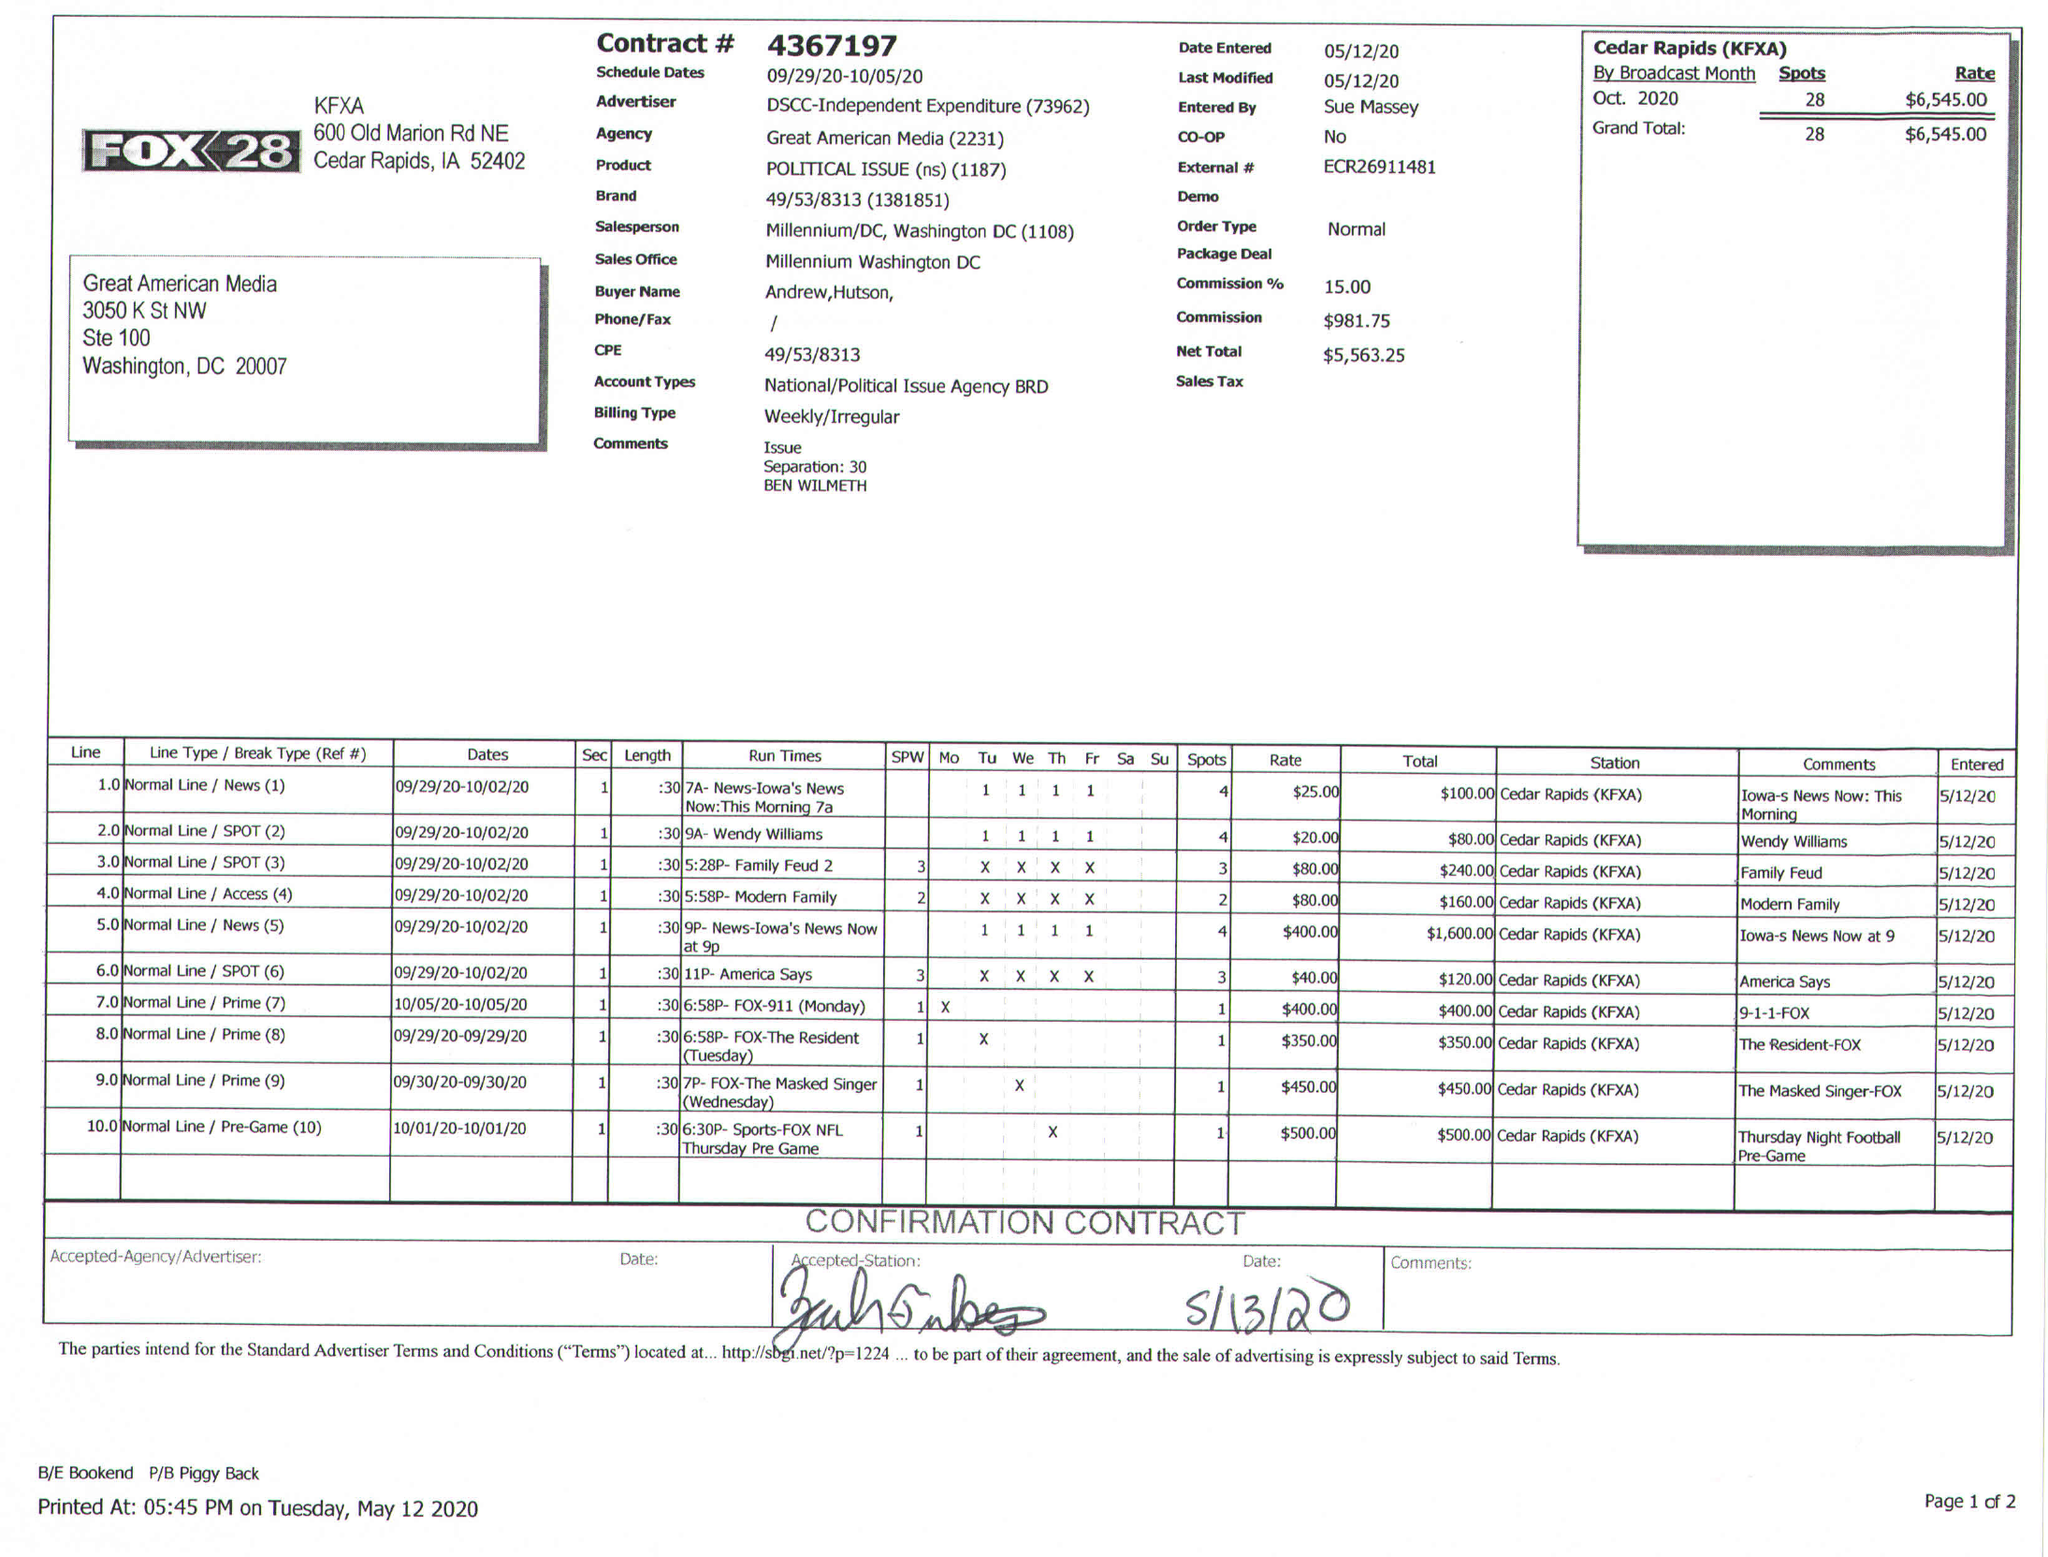What is the value for the contract_num?
Answer the question using a single word or phrase. 4367197 